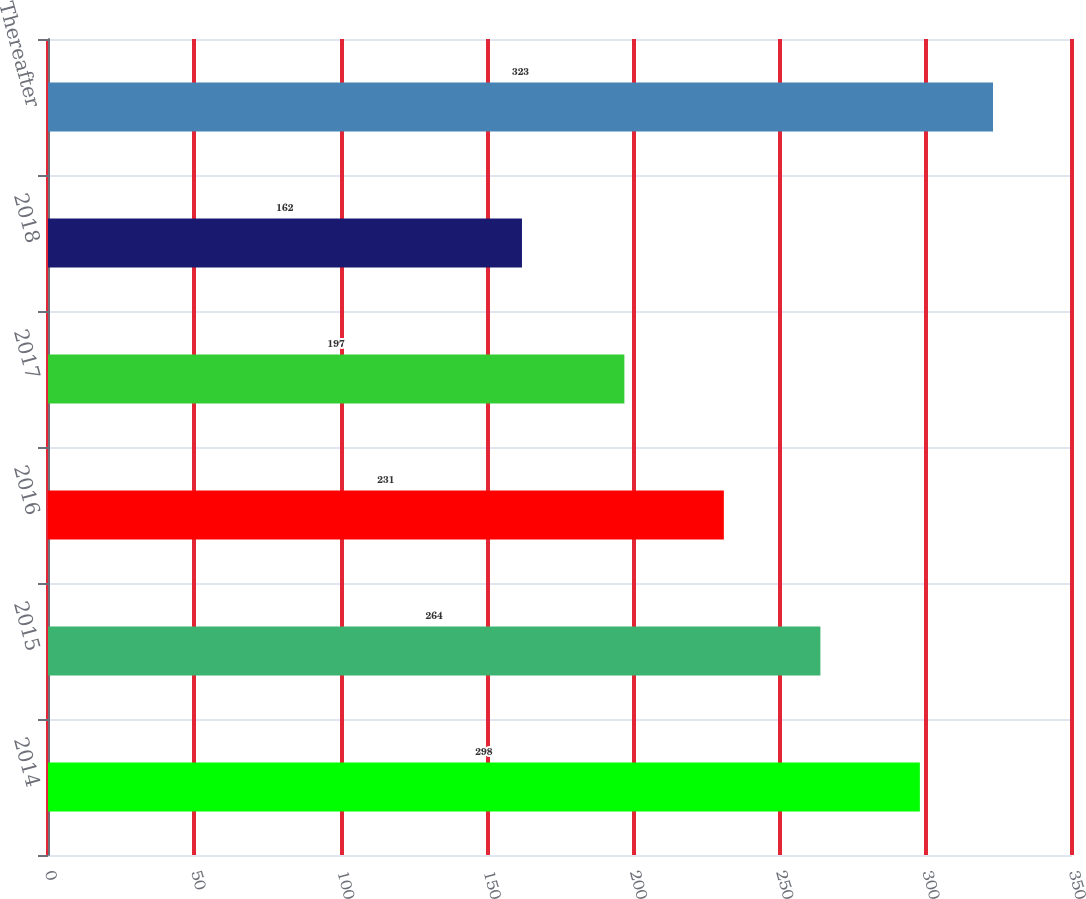Convert chart to OTSL. <chart><loc_0><loc_0><loc_500><loc_500><bar_chart><fcel>2014<fcel>2015<fcel>2016<fcel>2017<fcel>2018<fcel>Thereafter<nl><fcel>298<fcel>264<fcel>231<fcel>197<fcel>162<fcel>323<nl></chart> 